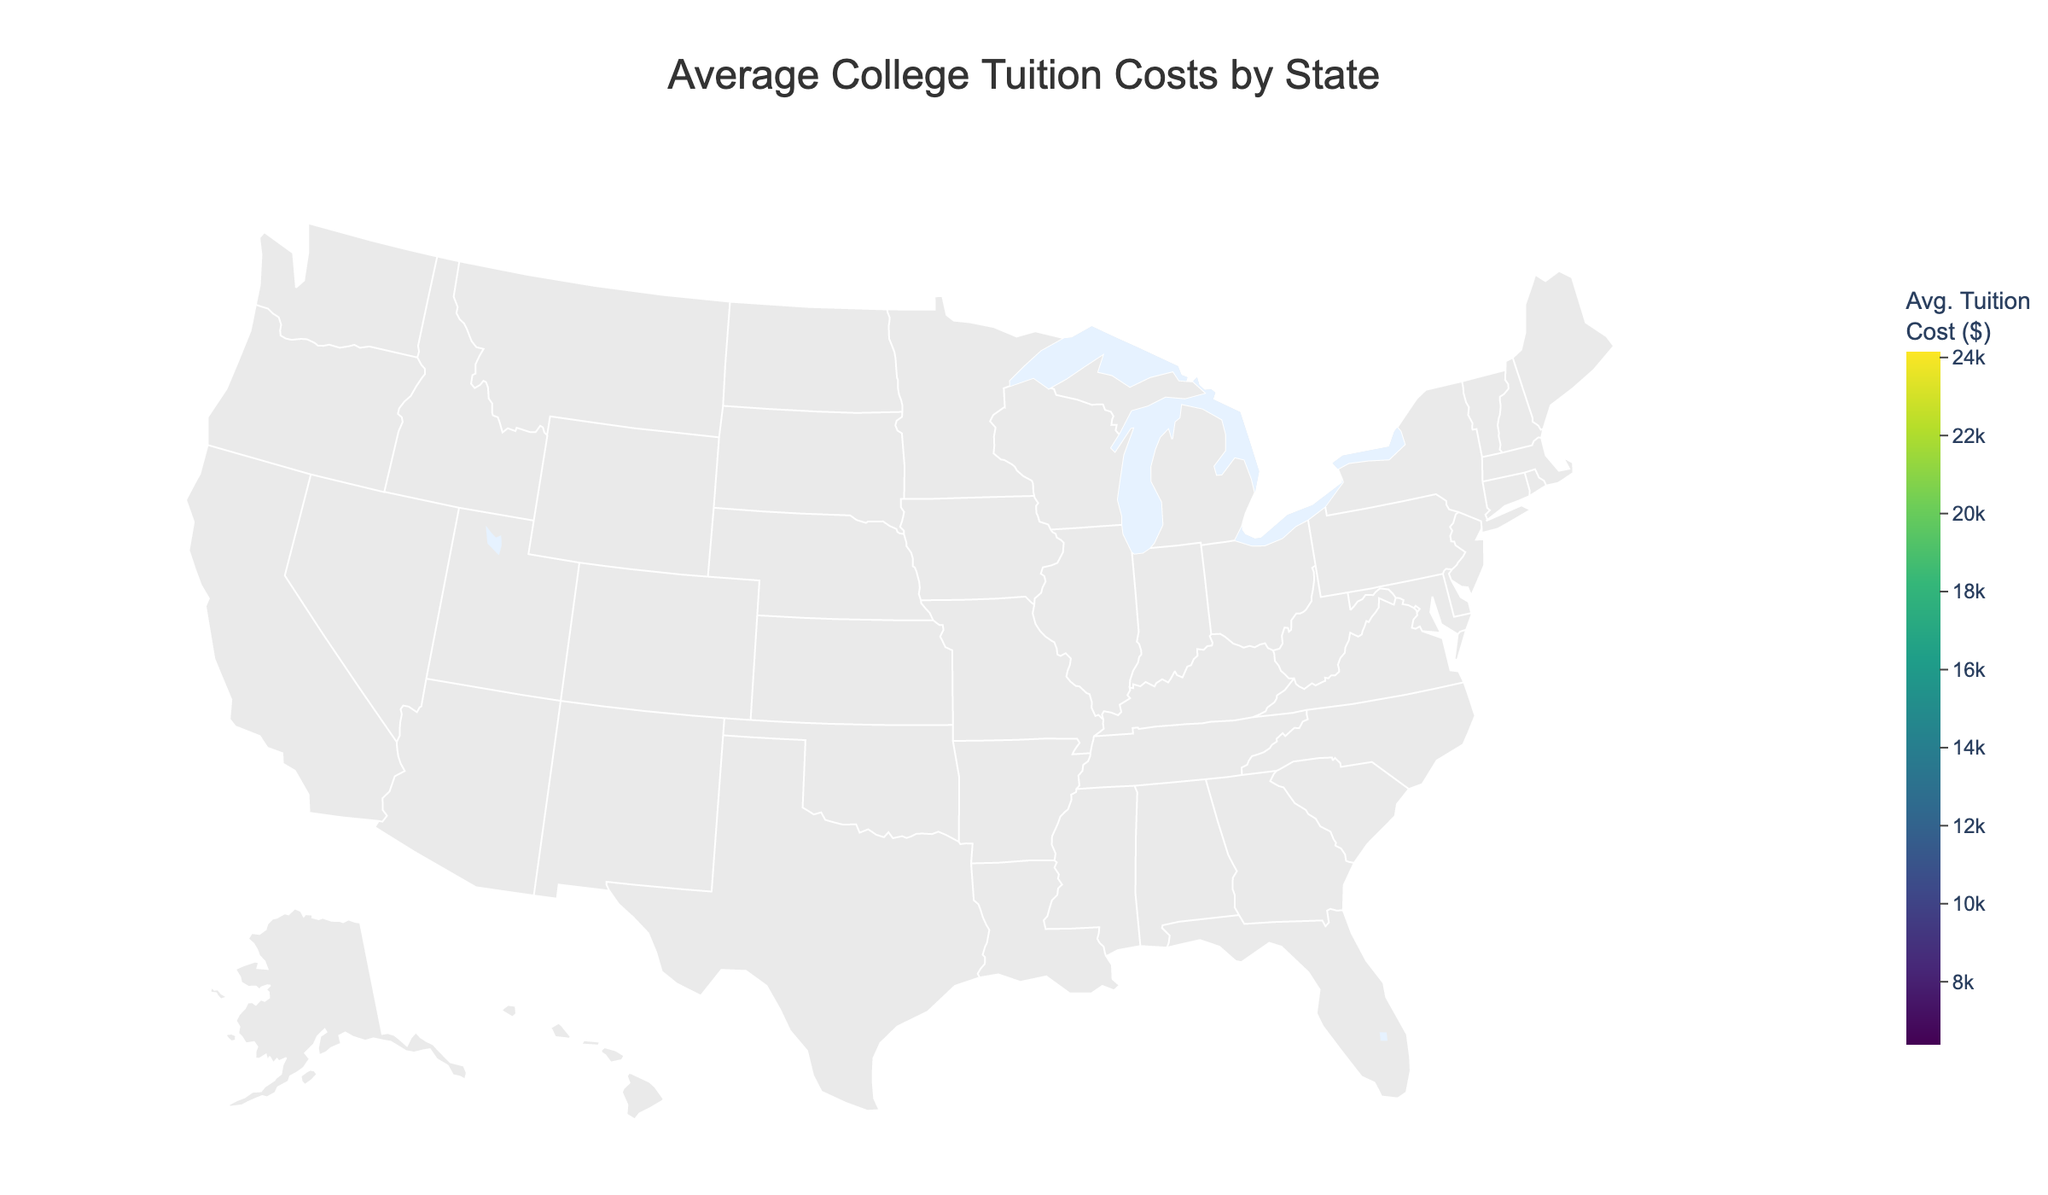What is the title of the map? The title of the map is usually found at the top of the figure. In this case, it states "Average College Tuition Costs by State".
Answer: Average College Tuition Costs by State Which state has the highest average tuition cost? To find the state with the highest average tuition, look for the state with the darkest color on the color scale. According to the figure, New York has the highest average tuition cost.
Answer: New York Which regions have lower tuition costs on average, and how can you tell? To determine which regions have lower tuition costs, we look for the regions with lighter colors on the color scale. The "South" region, particularly states like Florida and North Carolina, has lower tuition costs.
Answer: South What is the average tuition cost of Ohio? To find Ohio’s average tuition cost, locate Ohio on the map and check the corresponding value in the tooltip or color legend. Ohio has an average tuition cost of 10,197 dollars.
Answer: 10,197 Compare the average tuition costs between the Northeast and the South regions. Identify states in the Northeast and South regions and compare their average tuition costs. States in the Northeast, like New York or Pennsylvania, generally have higher tuition costs compared to states in the South, like Florida and Georgia.
Answer: Northeast > South What is the range of average tuition costs among the states shown? To find the range, identify the highest and lowest tuition costs on the map. The highest is New York (24,140 dollars) and the lowest is Florida (6,363 dollars). The range is 24,140 - 6,363 = 17,777 dollars.
Answer: 17,777 Which state in the Midwest has the highest average tuition cost and what is that cost? Locate the states in the Midwest and find the one with the darkest color. In this case, Illinois has the highest average tuition cost in the Midwest at 13,970 dollars.
Answer: Illinois, 13,970 How does the average tuition cost in California compare to Texas? Compare the values given for California and Texas. California’s average tuition is 14,229 dollars, while Texas’ is 10,204 dollars, so California's cost is higher.
Answer: California > Texas Is there a significant difference between tuition costs in the West region states of California and Washington? Compare the average tuition values for California (14,229 dollars) and Washington (10,370 dollars). California's tuition cost is significantly higher.
Answer: Yes, California > Washington What overall trends can be seen in the geographic distribution of tuition costs across the United States? From the color distribution on the map, it appears that states in the Northeast generally have higher tuition costs, while states in the South tend to have lower tuition costs. The Midwest and West have varied costs, with some states high and others lower.
Answer: Northeast higher, South lower, varied Midwest and West 